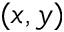Convert formula to latex. <formula><loc_0><loc_0><loc_500><loc_500>( x , y )</formula> 